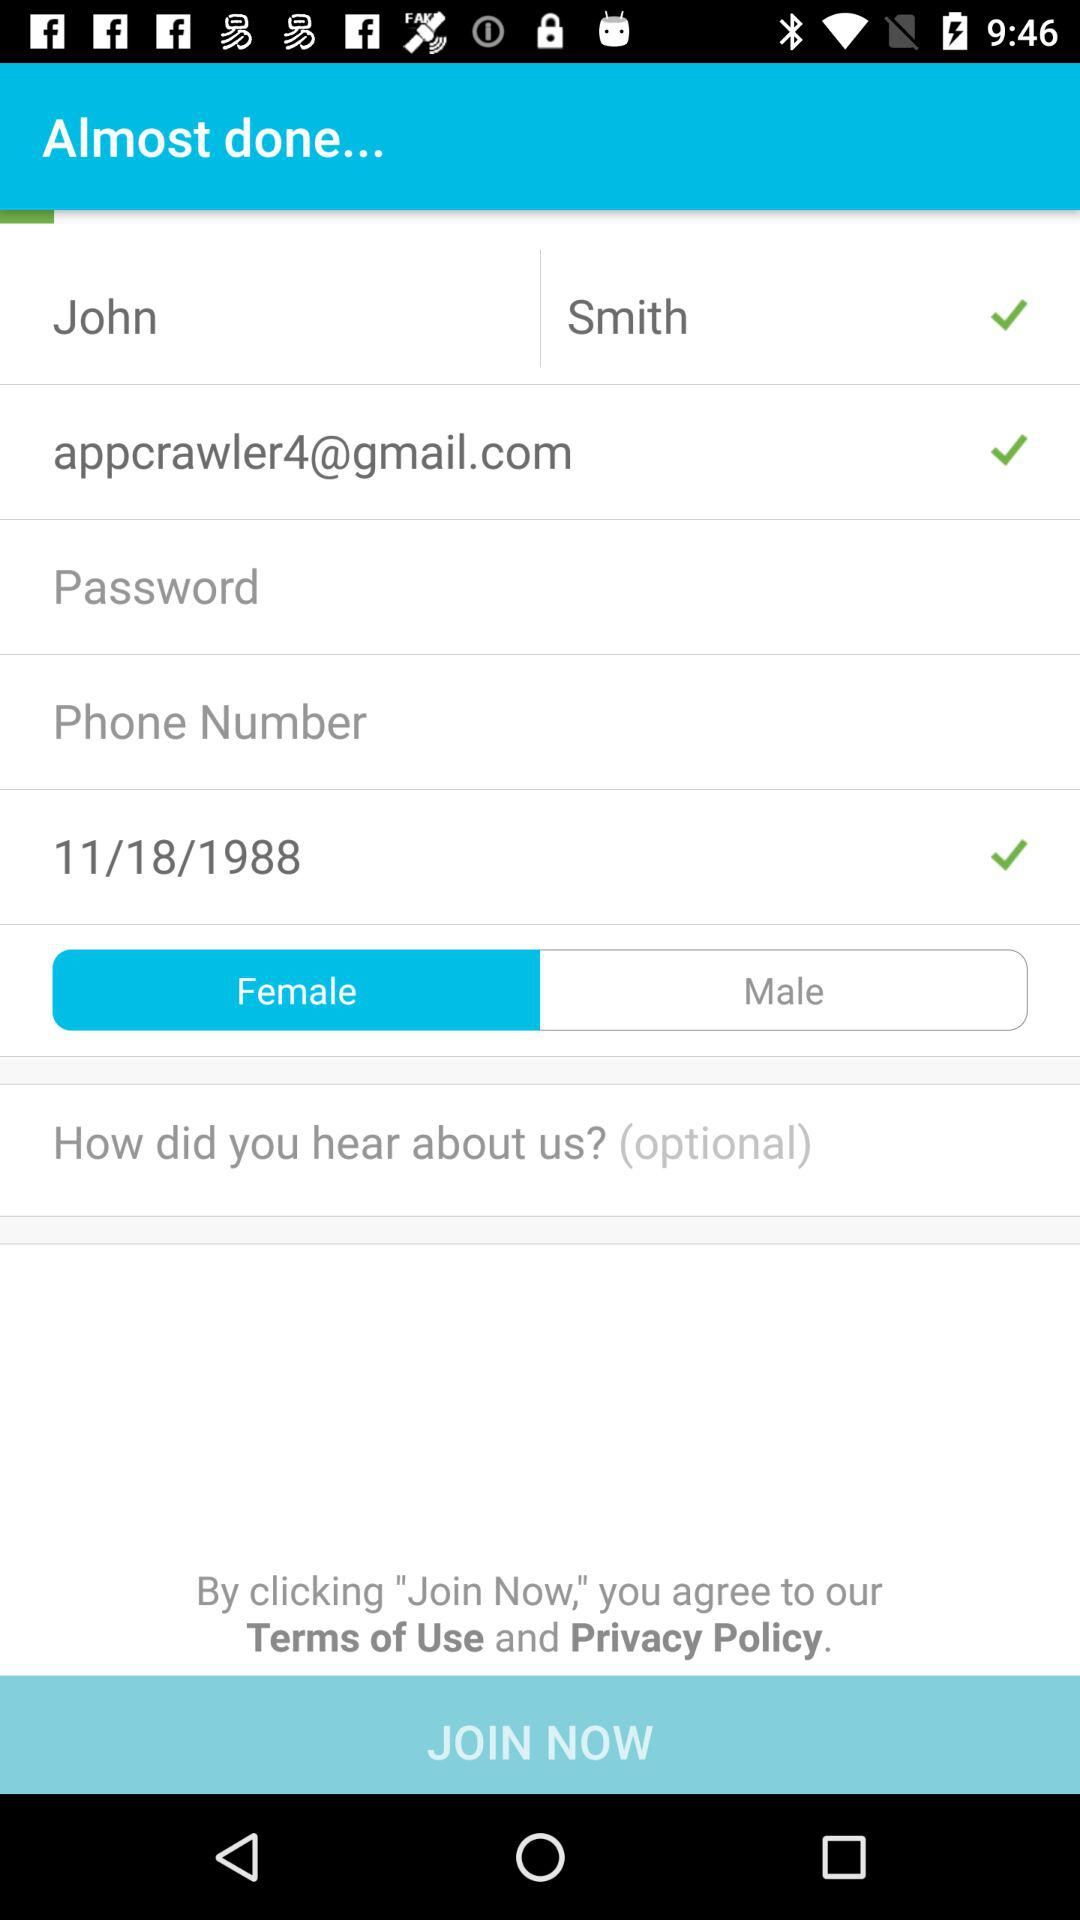What is the date of birth? The date of birth is November 18, 1988. 